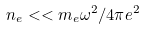Convert formula to latex. <formula><loc_0><loc_0><loc_500><loc_500>n _ { e } < < m _ { e } \omega ^ { 2 } / 4 \pi e ^ { 2 }</formula> 